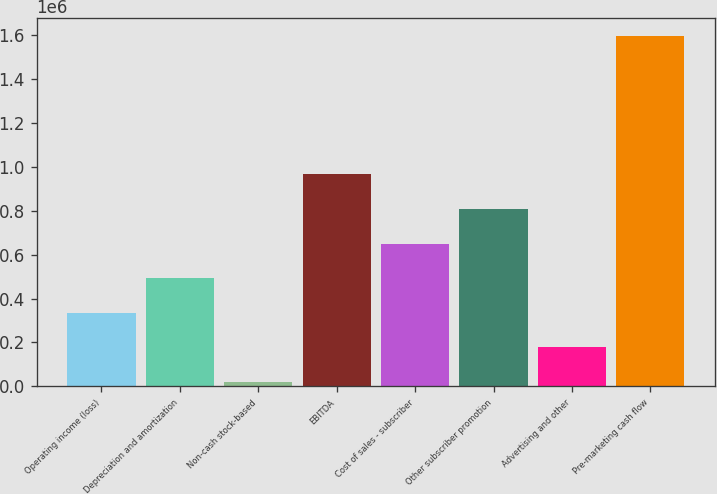Convert chart to OTSL. <chart><loc_0><loc_0><loc_500><loc_500><bar_chart><fcel>Operating income (loss)<fcel>Depreciation and amortization<fcel>Non-cash stock-based<fcel>EBITDA<fcel>Cost of sales - subscriber<fcel>Other subscriber promotion<fcel>Advertising and other<fcel>Pre-marketing cash flow<nl><fcel>335239<fcel>492772<fcel>20173<fcel>965370<fcel>650305<fcel>807838<fcel>177706<fcel>1.5955e+06<nl></chart> 